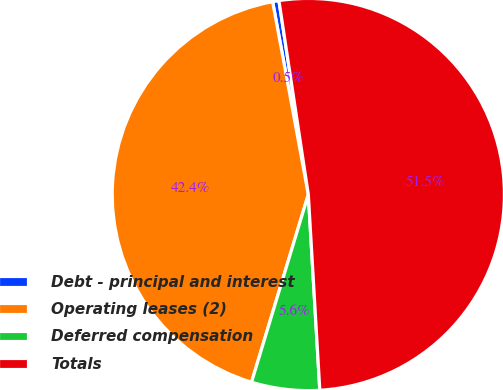Convert chart to OTSL. <chart><loc_0><loc_0><loc_500><loc_500><pie_chart><fcel>Debt - principal and interest<fcel>Operating leases (2)<fcel>Deferred compensation<fcel>Totals<nl><fcel>0.52%<fcel>42.41%<fcel>5.61%<fcel>51.46%<nl></chart> 